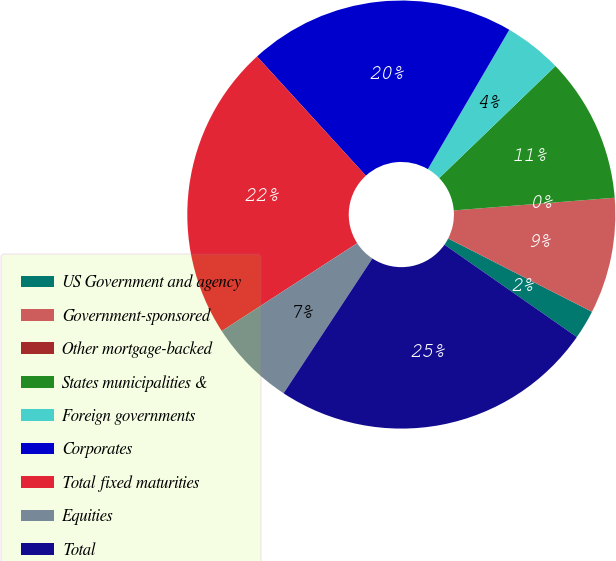<chart> <loc_0><loc_0><loc_500><loc_500><pie_chart><fcel>US Government and agency<fcel>Government-sponsored<fcel>Other mortgage-backed<fcel>States municipalities &<fcel>Foreign governments<fcel>Corporates<fcel>Total fixed maturities<fcel>Equities<fcel>Total<nl><fcel>2.19%<fcel>8.76%<fcel>0.0%<fcel>10.95%<fcel>4.38%<fcel>20.19%<fcel>22.38%<fcel>6.57%<fcel>24.57%<nl></chart> 